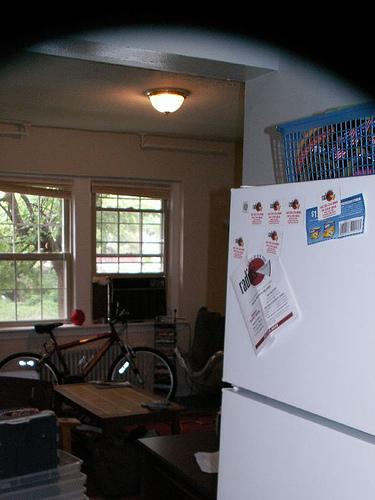Question: where is this location?
Choices:
A. Bathroom.
B. Porch.
C. Bedroom.
D. Kitchen.
Answer with the letter. Answer: D Question: what is on the refrigerator?
Choices:
A. Magnets and notes.
B. Pictures.
C. Stains.
D. Phone numbers.
Answer with the letter. Answer: A 